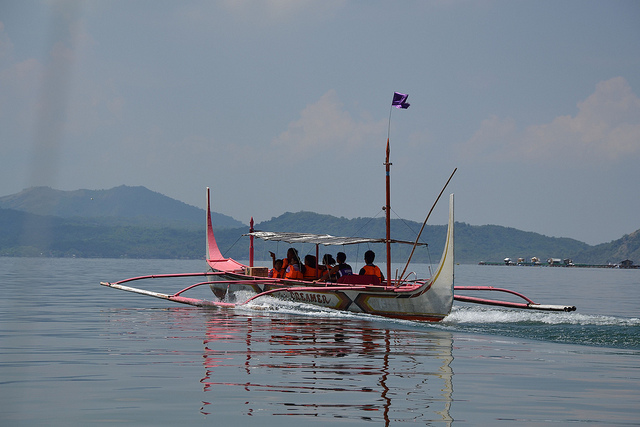Identify and read out the text in this image. CREAMER 